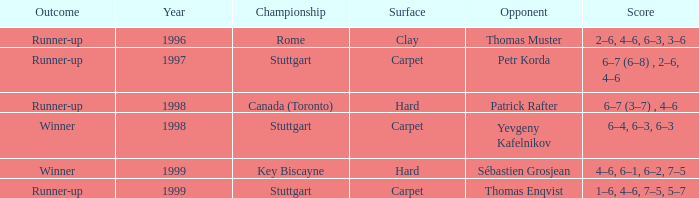How many years was the opponent petr korda? 1.0. 